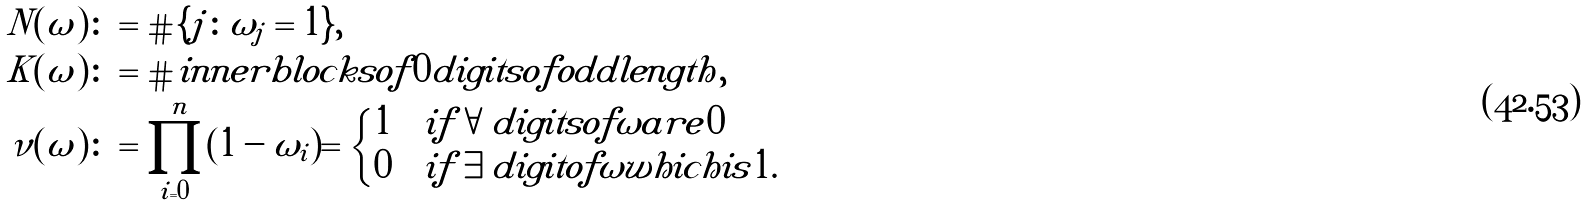Convert formula to latex. <formula><loc_0><loc_0><loc_500><loc_500>N ( \omega ) & \colon = \# \{ j \colon \omega _ { j } = 1 \} , \\ K ( \omega ) & \colon = \# i n n e r b l o c k s o f 0 d i g i t s o f o d d l e n g t h , \\ \nu ( \omega ) & \colon = \prod _ { i = 0 } ^ { n } ( 1 - \omega _ { i } ) = \begin{cases} 1 & i f \forall d i g i t s o f \omega a r e 0 \\ 0 & i f \exists d i g i t o f \omega w h i c h i s 1 . \end{cases}</formula> 